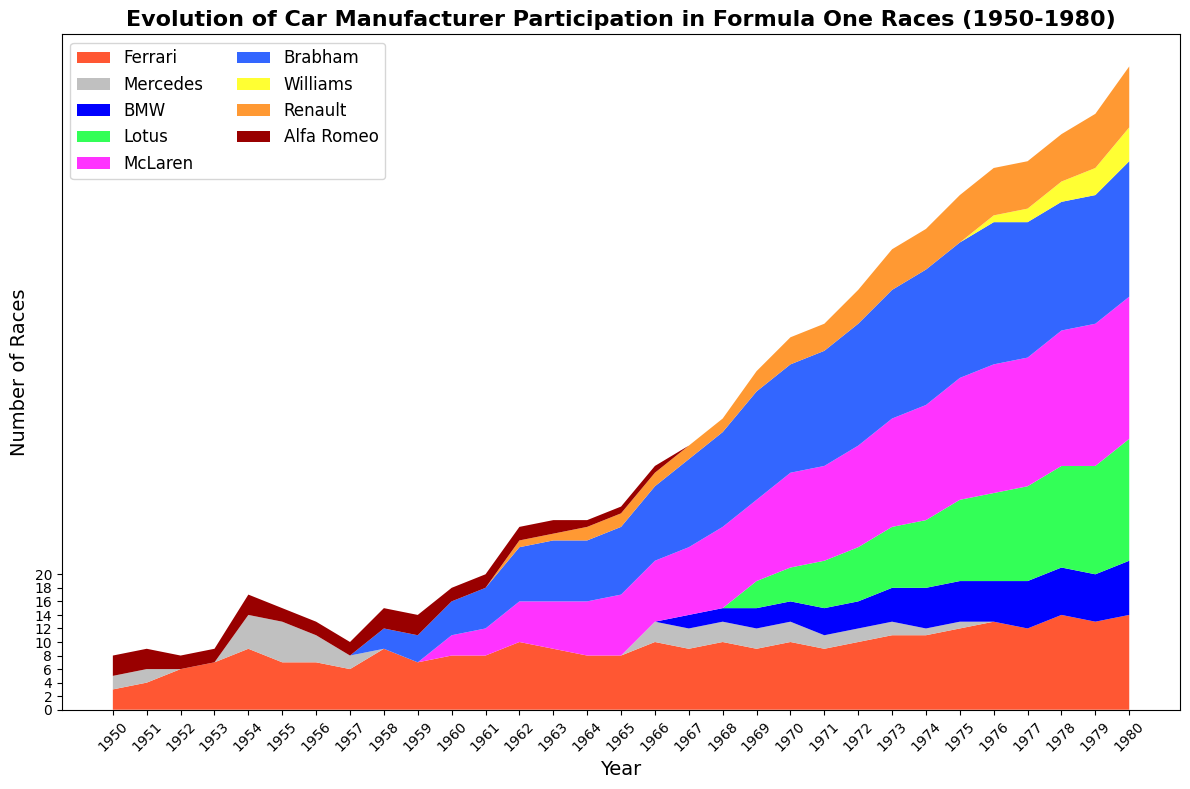What years did Ferrari participate in Formula One races more frequently than any other manufacturer? To determine the years when Ferrari had the highest participation, compare the heights of the Ferrari segments to the segments of other manufacturers in the area chart for each year. The chart shows Ferrari had the highest participation in almost all years from 1950 to 1980.
Answer: Almost every year When did Mercedes stop participating in Formula One races, and when did they reappear? Observe the area chart for the presence of the Mercedes segment. Mercedes stopped appearing after 1957 and reappeared in 1966.
Answer: 1957, 1966 Which manufacturer had the most consistent presence in the races from 1950 to 1980? Identify the manufacturer with a continuous, prominent segment throughout the entire timeline. The chart shows Ferrari having a consistent presence from 1950 to 1980.
Answer: Ferrari How did the entry of McLaren affect the participation landscape from the 1960s onwards? Note the introduction of McLaren in the 1960s and observe how the corresponding area changes, indicating increased participation. McLaren's participation started in 1966 and increased significantly, affecting the overall participation landscape by taking up more space in the area chart as the years progress.
Answer: Started in 1966, increased significantly Calculate the total number of races participated in by Renault in the 1970s. Sum the number of races Renault participated in over the years in the 1970s. From 1977 to 1980, Renault's participation is recorded as 7, 7, 7, and 8 races respectively. Calculating this gives: 7 + 7 + 7 + 8 = 29.
Answer: 29 Which manufacturer had no participation in the early 1950s but became a significant participant in the 1970s? Note the absence of certain manufacturers in the 1950s and their rise in participation in the 1970s. Williams is absent in the early 1950s but becomes a significant participant in the 1970s.
Answer: Williams Compare the participation of BMW and Lotus in 1968. Which had a higher number of races, and by how much? Look at the area chart for the year 1968 and observe the heights of the BMW (blue) and Lotus (green) segments. BMW participated in 2 races, while Lotus participated in 4 races. The difference is 4 - 2 = 2.
Answer: Lotus, by 2 races Which years show an increase in participation for Alfa Romeo while other manufacturers showed a decrease? Observe the trend of Alfa Romeo's participation and compare it to the trends of other manufacturers. In 1958, Alfa Romeo's participation increases while Mercedes' participation decreases. Another significant increase for Alfa Romeo is in the 1980s, but the other manufacturers like Ferrari and McLaren also increased or maintained their presence.
Answer: 1958 What period saw the highest diversity in car manufacturers participating in Formula One races? Look for periods in the area chart with the most colors and segments, indicating diverse participation. The highest diversity is observed in the 1970s as multiple manufacturers like Ferrari, McLaren, Brabham, Lotus, and others were participating actively.
Answer: 1970s Did any manufacturer maintain total dominance in any given year? If so, which years and manufacturers? A total dominance would mean only one manufacturer is visible as participating. From the chart, Ferrari dominates several years like 1952 and 1953 when very few other manufacturers have bars.
Answer: 1952, 1953 (Ferrari) 